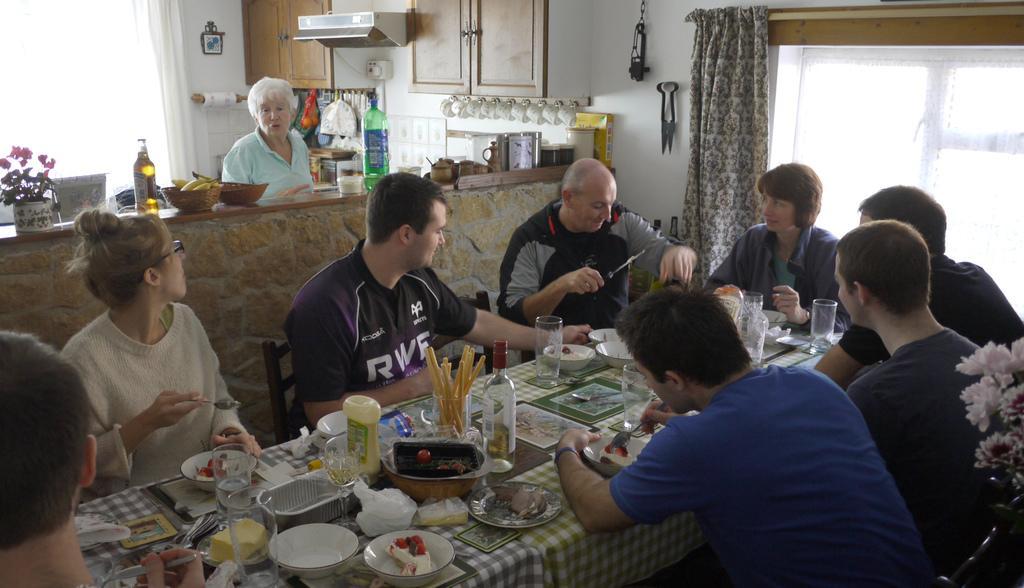In one or two sentences, can you explain what this image depicts? In the image we can see few persons were sitting around the table. On table we can see bottle,glass,bowl,tissue paper,spoon and food item. In the background there is a cupboard,wall,curtain,window,flower pot,bottle,banana. 